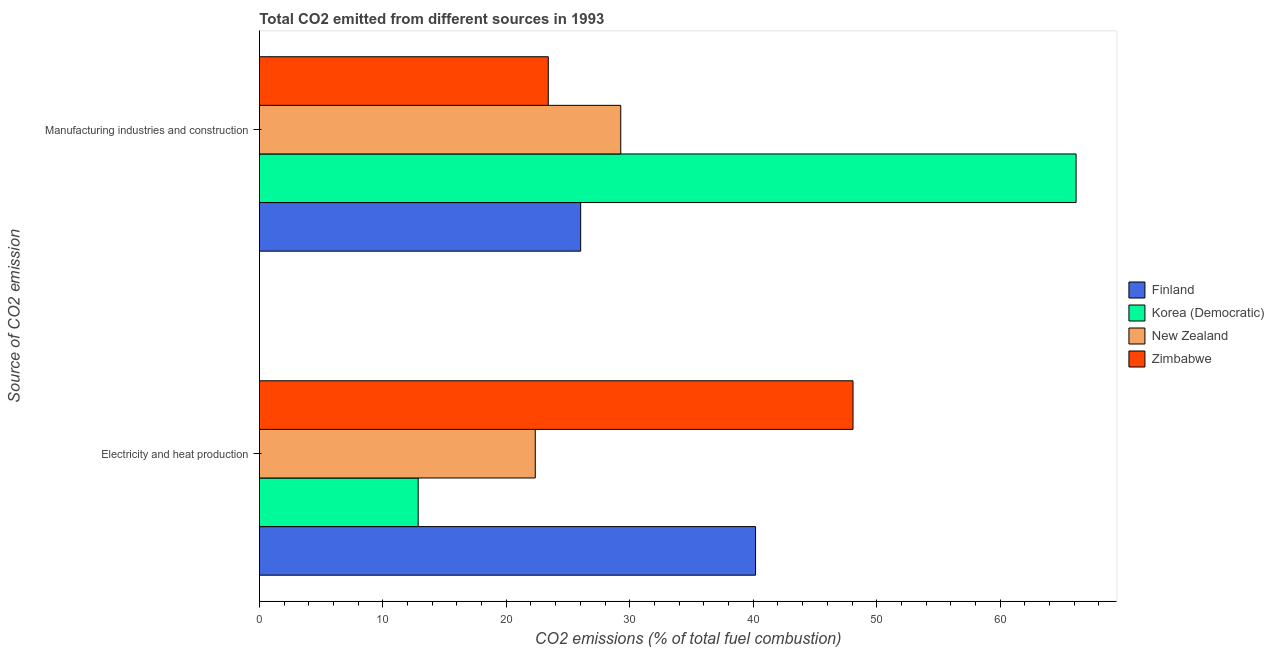Are the number of bars per tick equal to the number of legend labels?
Your response must be concise. Yes. Are the number of bars on each tick of the Y-axis equal?
Keep it short and to the point. Yes. How many bars are there on the 1st tick from the top?
Your answer should be compact. 4. How many bars are there on the 1st tick from the bottom?
Give a very brief answer. 4. What is the label of the 2nd group of bars from the top?
Provide a short and direct response. Electricity and heat production. What is the co2 emissions due to manufacturing industries in Finland?
Your answer should be very brief. 26.02. Across all countries, what is the maximum co2 emissions due to electricity and heat production?
Your answer should be compact. 48.08. Across all countries, what is the minimum co2 emissions due to manufacturing industries?
Your answer should be very brief. 23.4. In which country was the co2 emissions due to electricity and heat production maximum?
Make the answer very short. Zimbabwe. In which country was the co2 emissions due to manufacturing industries minimum?
Ensure brevity in your answer.  Zimbabwe. What is the total co2 emissions due to electricity and heat production in the graph?
Provide a succinct answer. 123.48. What is the difference between the co2 emissions due to manufacturing industries in Korea (Democratic) and that in Zimbabwe?
Your answer should be very brief. 42.75. What is the difference between the co2 emissions due to electricity and heat production in New Zealand and the co2 emissions due to manufacturing industries in Zimbabwe?
Your response must be concise. -1.05. What is the average co2 emissions due to electricity and heat production per country?
Your response must be concise. 30.87. What is the difference between the co2 emissions due to manufacturing industries and co2 emissions due to electricity and heat production in New Zealand?
Ensure brevity in your answer.  6.92. What is the ratio of the co2 emissions due to electricity and heat production in Finland to that in New Zealand?
Offer a terse response. 1.8. Is the co2 emissions due to electricity and heat production in Zimbabwe less than that in Korea (Democratic)?
Offer a terse response. No. In how many countries, is the co2 emissions due to electricity and heat production greater than the average co2 emissions due to electricity and heat production taken over all countries?
Make the answer very short. 2. What does the 2nd bar from the top in Manufacturing industries and construction represents?
Your answer should be very brief. New Zealand. What does the 2nd bar from the bottom in Manufacturing industries and construction represents?
Provide a short and direct response. Korea (Democratic). How many bars are there?
Provide a short and direct response. 8. How many countries are there in the graph?
Your answer should be very brief. 4. What is the difference between two consecutive major ticks on the X-axis?
Your answer should be compact. 10. Does the graph contain any zero values?
Make the answer very short. No. Where does the legend appear in the graph?
Ensure brevity in your answer.  Center right. How many legend labels are there?
Provide a short and direct response. 4. How are the legend labels stacked?
Your answer should be very brief. Vertical. What is the title of the graph?
Make the answer very short. Total CO2 emitted from different sources in 1993. What is the label or title of the X-axis?
Ensure brevity in your answer.  CO2 emissions (% of total fuel combustion). What is the label or title of the Y-axis?
Provide a succinct answer. Source of CO2 emission. What is the CO2 emissions (% of total fuel combustion) of Finland in Electricity and heat production?
Ensure brevity in your answer.  40.19. What is the CO2 emissions (% of total fuel combustion) in Korea (Democratic) in Electricity and heat production?
Provide a short and direct response. 12.86. What is the CO2 emissions (% of total fuel combustion) in New Zealand in Electricity and heat production?
Provide a succinct answer. 22.35. What is the CO2 emissions (% of total fuel combustion) of Zimbabwe in Electricity and heat production?
Make the answer very short. 48.08. What is the CO2 emissions (% of total fuel combustion) in Finland in Manufacturing industries and construction?
Offer a terse response. 26.02. What is the CO2 emissions (% of total fuel combustion) in Korea (Democratic) in Manufacturing industries and construction?
Ensure brevity in your answer.  66.15. What is the CO2 emissions (% of total fuel combustion) of New Zealand in Manufacturing industries and construction?
Offer a terse response. 29.27. What is the CO2 emissions (% of total fuel combustion) in Zimbabwe in Manufacturing industries and construction?
Offer a very short reply. 23.4. Across all Source of CO2 emission, what is the maximum CO2 emissions (% of total fuel combustion) of Finland?
Keep it short and to the point. 40.19. Across all Source of CO2 emission, what is the maximum CO2 emissions (% of total fuel combustion) in Korea (Democratic)?
Give a very brief answer. 66.15. Across all Source of CO2 emission, what is the maximum CO2 emissions (% of total fuel combustion) of New Zealand?
Keep it short and to the point. 29.27. Across all Source of CO2 emission, what is the maximum CO2 emissions (% of total fuel combustion) in Zimbabwe?
Offer a terse response. 48.08. Across all Source of CO2 emission, what is the minimum CO2 emissions (% of total fuel combustion) in Finland?
Ensure brevity in your answer.  26.02. Across all Source of CO2 emission, what is the minimum CO2 emissions (% of total fuel combustion) in Korea (Democratic)?
Provide a succinct answer. 12.86. Across all Source of CO2 emission, what is the minimum CO2 emissions (% of total fuel combustion) of New Zealand?
Ensure brevity in your answer.  22.35. Across all Source of CO2 emission, what is the minimum CO2 emissions (% of total fuel combustion) in Zimbabwe?
Keep it short and to the point. 23.4. What is the total CO2 emissions (% of total fuel combustion) of Finland in the graph?
Provide a succinct answer. 66.21. What is the total CO2 emissions (% of total fuel combustion) in Korea (Democratic) in the graph?
Keep it short and to the point. 79.01. What is the total CO2 emissions (% of total fuel combustion) of New Zealand in the graph?
Offer a very short reply. 51.62. What is the total CO2 emissions (% of total fuel combustion) of Zimbabwe in the graph?
Ensure brevity in your answer.  71.48. What is the difference between the CO2 emissions (% of total fuel combustion) of Finland in Electricity and heat production and that in Manufacturing industries and construction?
Your response must be concise. 14.16. What is the difference between the CO2 emissions (% of total fuel combustion) in Korea (Democratic) in Electricity and heat production and that in Manufacturing industries and construction?
Provide a short and direct response. -53.28. What is the difference between the CO2 emissions (% of total fuel combustion) of New Zealand in Electricity and heat production and that in Manufacturing industries and construction?
Ensure brevity in your answer.  -6.92. What is the difference between the CO2 emissions (% of total fuel combustion) in Zimbabwe in Electricity and heat production and that in Manufacturing industries and construction?
Make the answer very short. 24.68. What is the difference between the CO2 emissions (% of total fuel combustion) in Finland in Electricity and heat production and the CO2 emissions (% of total fuel combustion) in Korea (Democratic) in Manufacturing industries and construction?
Make the answer very short. -25.96. What is the difference between the CO2 emissions (% of total fuel combustion) in Finland in Electricity and heat production and the CO2 emissions (% of total fuel combustion) in New Zealand in Manufacturing industries and construction?
Give a very brief answer. 10.92. What is the difference between the CO2 emissions (% of total fuel combustion) of Finland in Electricity and heat production and the CO2 emissions (% of total fuel combustion) of Zimbabwe in Manufacturing industries and construction?
Give a very brief answer. 16.79. What is the difference between the CO2 emissions (% of total fuel combustion) of Korea (Democratic) in Electricity and heat production and the CO2 emissions (% of total fuel combustion) of New Zealand in Manufacturing industries and construction?
Provide a short and direct response. -16.41. What is the difference between the CO2 emissions (% of total fuel combustion) of Korea (Democratic) in Electricity and heat production and the CO2 emissions (% of total fuel combustion) of Zimbabwe in Manufacturing industries and construction?
Your response must be concise. -10.54. What is the difference between the CO2 emissions (% of total fuel combustion) in New Zealand in Electricity and heat production and the CO2 emissions (% of total fuel combustion) in Zimbabwe in Manufacturing industries and construction?
Offer a very short reply. -1.05. What is the average CO2 emissions (% of total fuel combustion) in Finland per Source of CO2 emission?
Offer a terse response. 33.1. What is the average CO2 emissions (% of total fuel combustion) of Korea (Democratic) per Source of CO2 emission?
Keep it short and to the point. 39.51. What is the average CO2 emissions (% of total fuel combustion) of New Zealand per Source of CO2 emission?
Ensure brevity in your answer.  25.81. What is the average CO2 emissions (% of total fuel combustion) in Zimbabwe per Source of CO2 emission?
Offer a terse response. 35.74. What is the difference between the CO2 emissions (% of total fuel combustion) in Finland and CO2 emissions (% of total fuel combustion) in Korea (Democratic) in Electricity and heat production?
Your answer should be compact. 27.32. What is the difference between the CO2 emissions (% of total fuel combustion) in Finland and CO2 emissions (% of total fuel combustion) in New Zealand in Electricity and heat production?
Your answer should be compact. 17.84. What is the difference between the CO2 emissions (% of total fuel combustion) of Finland and CO2 emissions (% of total fuel combustion) of Zimbabwe in Electricity and heat production?
Offer a very short reply. -7.89. What is the difference between the CO2 emissions (% of total fuel combustion) in Korea (Democratic) and CO2 emissions (% of total fuel combustion) in New Zealand in Electricity and heat production?
Keep it short and to the point. -9.48. What is the difference between the CO2 emissions (% of total fuel combustion) of Korea (Democratic) and CO2 emissions (% of total fuel combustion) of Zimbabwe in Electricity and heat production?
Offer a very short reply. -35.22. What is the difference between the CO2 emissions (% of total fuel combustion) of New Zealand and CO2 emissions (% of total fuel combustion) of Zimbabwe in Electricity and heat production?
Give a very brief answer. -25.73. What is the difference between the CO2 emissions (% of total fuel combustion) in Finland and CO2 emissions (% of total fuel combustion) in Korea (Democratic) in Manufacturing industries and construction?
Your response must be concise. -40.12. What is the difference between the CO2 emissions (% of total fuel combustion) of Finland and CO2 emissions (% of total fuel combustion) of New Zealand in Manufacturing industries and construction?
Make the answer very short. -3.25. What is the difference between the CO2 emissions (% of total fuel combustion) of Finland and CO2 emissions (% of total fuel combustion) of Zimbabwe in Manufacturing industries and construction?
Give a very brief answer. 2.62. What is the difference between the CO2 emissions (% of total fuel combustion) in Korea (Democratic) and CO2 emissions (% of total fuel combustion) in New Zealand in Manufacturing industries and construction?
Keep it short and to the point. 36.88. What is the difference between the CO2 emissions (% of total fuel combustion) in Korea (Democratic) and CO2 emissions (% of total fuel combustion) in Zimbabwe in Manufacturing industries and construction?
Your answer should be very brief. 42.75. What is the difference between the CO2 emissions (% of total fuel combustion) in New Zealand and CO2 emissions (% of total fuel combustion) in Zimbabwe in Manufacturing industries and construction?
Your response must be concise. 5.87. What is the ratio of the CO2 emissions (% of total fuel combustion) of Finland in Electricity and heat production to that in Manufacturing industries and construction?
Your response must be concise. 1.54. What is the ratio of the CO2 emissions (% of total fuel combustion) in Korea (Democratic) in Electricity and heat production to that in Manufacturing industries and construction?
Offer a very short reply. 0.19. What is the ratio of the CO2 emissions (% of total fuel combustion) in New Zealand in Electricity and heat production to that in Manufacturing industries and construction?
Offer a very short reply. 0.76. What is the ratio of the CO2 emissions (% of total fuel combustion) in Zimbabwe in Electricity and heat production to that in Manufacturing industries and construction?
Provide a short and direct response. 2.05. What is the difference between the highest and the second highest CO2 emissions (% of total fuel combustion) in Finland?
Keep it short and to the point. 14.16. What is the difference between the highest and the second highest CO2 emissions (% of total fuel combustion) of Korea (Democratic)?
Your response must be concise. 53.28. What is the difference between the highest and the second highest CO2 emissions (% of total fuel combustion) of New Zealand?
Offer a very short reply. 6.92. What is the difference between the highest and the second highest CO2 emissions (% of total fuel combustion) in Zimbabwe?
Offer a terse response. 24.68. What is the difference between the highest and the lowest CO2 emissions (% of total fuel combustion) in Finland?
Offer a terse response. 14.16. What is the difference between the highest and the lowest CO2 emissions (% of total fuel combustion) in Korea (Democratic)?
Keep it short and to the point. 53.28. What is the difference between the highest and the lowest CO2 emissions (% of total fuel combustion) of New Zealand?
Your response must be concise. 6.92. What is the difference between the highest and the lowest CO2 emissions (% of total fuel combustion) in Zimbabwe?
Offer a very short reply. 24.68. 